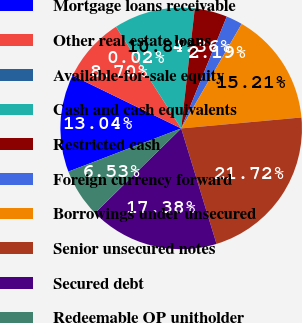Convert chart. <chart><loc_0><loc_0><loc_500><loc_500><pie_chart><fcel>Mortgage loans receivable<fcel>Other real estate loans<fcel>Available-for-sale equity<fcel>Cash and cash equivalents<fcel>Restricted cash<fcel>Foreign currency forward<fcel>Borrowings under unsecured<fcel>Senior unsecured notes<fcel>Secured debt<fcel>Redeemable OP unitholder<nl><fcel>13.04%<fcel>8.7%<fcel>0.02%<fcel>10.87%<fcel>4.36%<fcel>2.19%<fcel>15.21%<fcel>21.72%<fcel>17.38%<fcel>6.53%<nl></chart> 